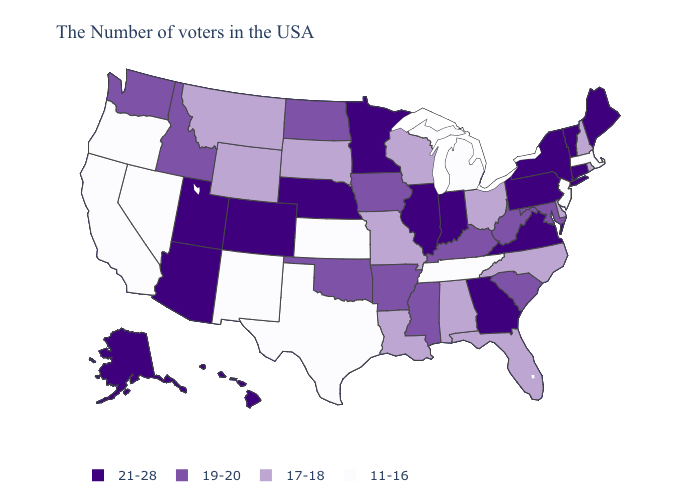What is the value of Nevada?
Quick response, please. 11-16. Name the states that have a value in the range 11-16?
Short answer required. Massachusetts, New Jersey, Michigan, Tennessee, Kansas, Texas, New Mexico, Nevada, California, Oregon. Name the states that have a value in the range 19-20?
Short answer required. Maryland, South Carolina, West Virginia, Kentucky, Mississippi, Arkansas, Iowa, Oklahoma, North Dakota, Idaho, Washington. Does the first symbol in the legend represent the smallest category?
Write a very short answer. No. What is the value of Montana?
Answer briefly. 17-18. Name the states that have a value in the range 17-18?
Be succinct. Rhode Island, New Hampshire, Delaware, North Carolina, Ohio, Florida, Alabama, Wisconsin, Louisiana, Missouri, South Dakota, Wyoming, Montana. What is the value of West Virginia?
Keep it brief. 19-20. What is the value of Utah?
Be succinct. 21-28. What is the highest value in the USA?
Be succinct. 21-28. What is the lowest value in the USA?
Concise answer only. 11-16. Does New York have the lowest value in the Northeast?
Short answer required. No. Does Kentucky have a lower value than Maryland?
Answer briefly. No. Name the states that have a value in the range 17-18?
Concise answer only. Rhode Island, New Hampshire, Delaware, North Carolina, Ohio, Florida, Alabama, Wisconsin, Louisiana, Missouri, South Dakota, Wyoming, Montana. What is the lowest value in states that border Louisiana?
Be succinct. 11-16. Which states have the lowest value in the West?
Write a very short answer. New Mexico, Nevada, California, Oregon. 